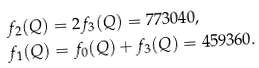<formula> <loc_0><loc_0><loc_500><loc_500>f _ { 2 } ( Q ) & = 2 f _ { 3 } ( Q ) = 7 7 3 0 4 0 , \\ f _ { 1 } ( Q ) & = f _ { 0 } ( Q ) + f _ { 3 } ( Q ) = 4 5 9 3 6 0 .</formula> 